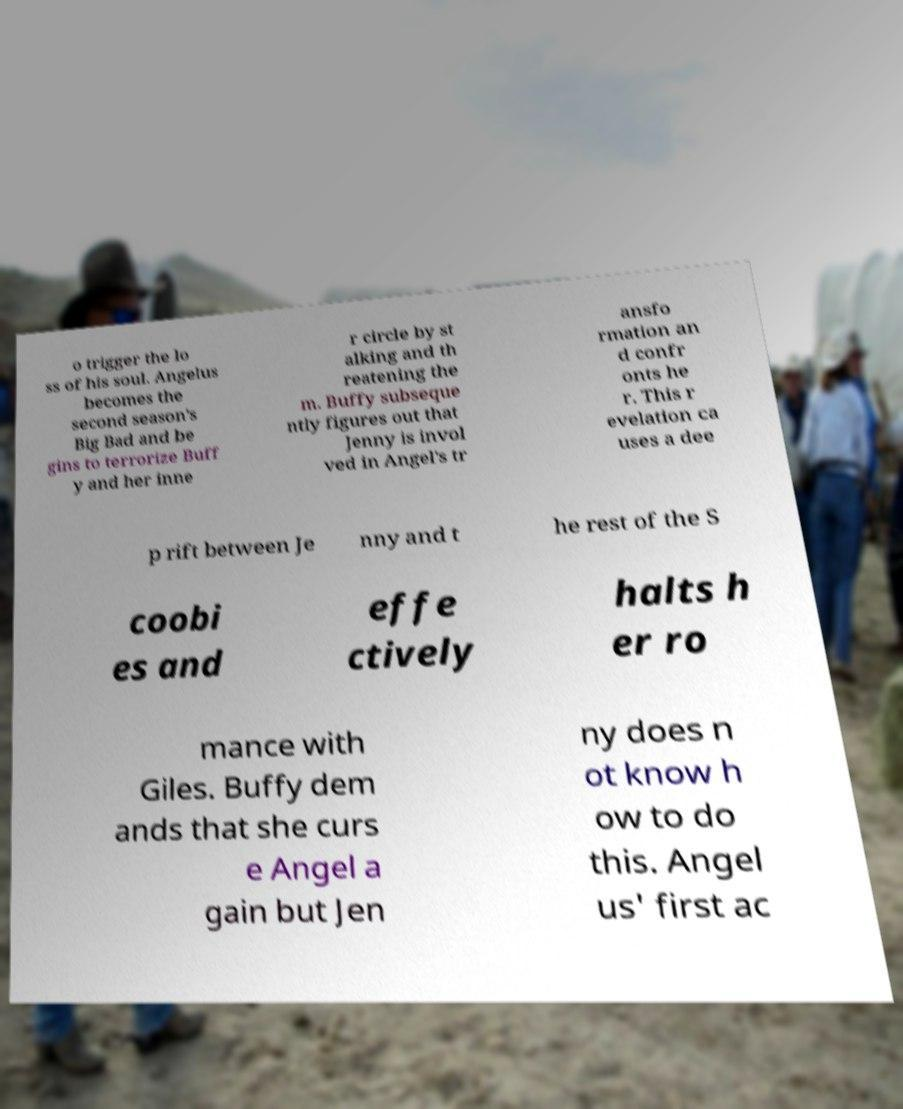Can you read and provide the text displayed in the image?This photo seems to have some interesting text. Can you extract and type it out for me? o trigger the lo ss of his soul. Angelus becomes the second season's Big Bad and be gins to terrorize Buff y and her inne r circle by st alking and th reatening the m. Buffy subseque ntly figures out that Jenny is invol ved in Angel's tr ansfo rmation an d confr onts he r. This r evelation ca uses a dee p rift between Je nny and t he rest of the S coobi es and effe ctively halts h er ro mance with Giles. Buffy dem ands that she curs e Angel a gain but Jen ny does n ot know h ow to do this. Angel us' first ac 